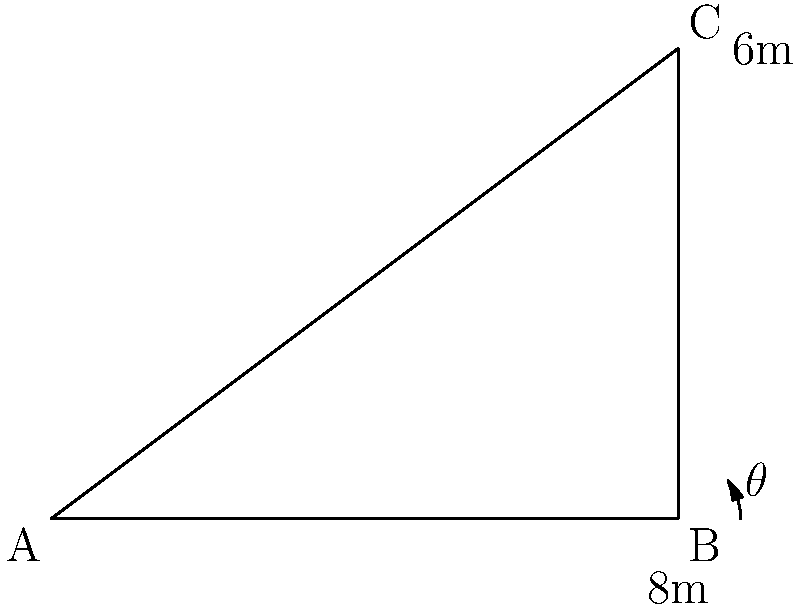In an office renovation project, you need to route a network cable from point A to point C along the wall and ceiling. Given that the horizontal distance AB is 8 meters and the vertical distance BC is 6 meters, calculate the angle of inclination $\theta$ (in degrees) for optimal cable routing. Round your answer to the nearest whole degree. To find the angle of inclination $\theta$, we can use the trigonometric function tangent. Here's how to solve it step-by-step:

1) In the right triangle ABC, we know:
   - The opposite side (BC) = 6 meters
   - The adjacent side (AB) = 8 meters

2) The tangent of an angle is defined as the ratio of the opposite side to the adjacent side:

   $\tan(\theta) = \frac{\text{opposite}}{\text{adjacent}} = \frac{\text{BC}}{\text{AB}}$

3) Substituting the known values:

   $\tan(\theta) = \frac{6}{8} = 0.75$

4) To find $\theta$, we need to use the inverse tangent (arctan or $\tan^{-1}$) function:

   $\theta = \tan^{-1}(0.75)$

5) Using a calculator or computer:

   $\theta \approx 36.87°$

6) Rounding to the nearest whole degree:

   $\theta \approx 37°$

Therefore, the optimal angle of inclination for the cable routing is approximately 37 degrees.
Answer: 37° 